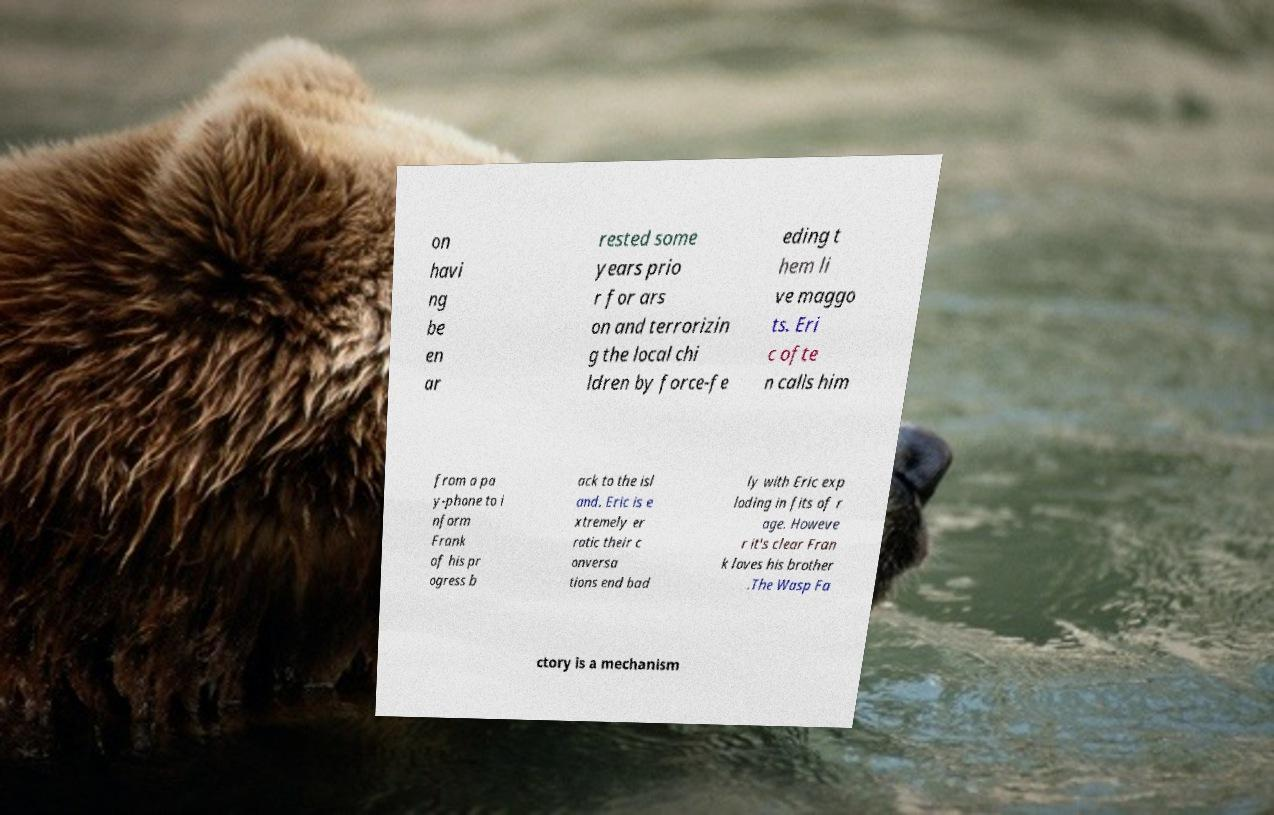Please identify and transcribe the text found in this image. on havi ng be en ar rested some years prio r for ars on and terrorizin g the local chi ldren by force-fe eding t hem li ve maggo ts. Eri c ofte n calls him from a pa y-phone to i nform Frank of his pr ogress b ack to the isl and. Eric is e xtremely er ratic their c onversa tions end bad ly with Eric exp loding in fits of r age. Howeve r it's clear Fran k loves his brother .The Wasp Fa ctory is a mechanism 